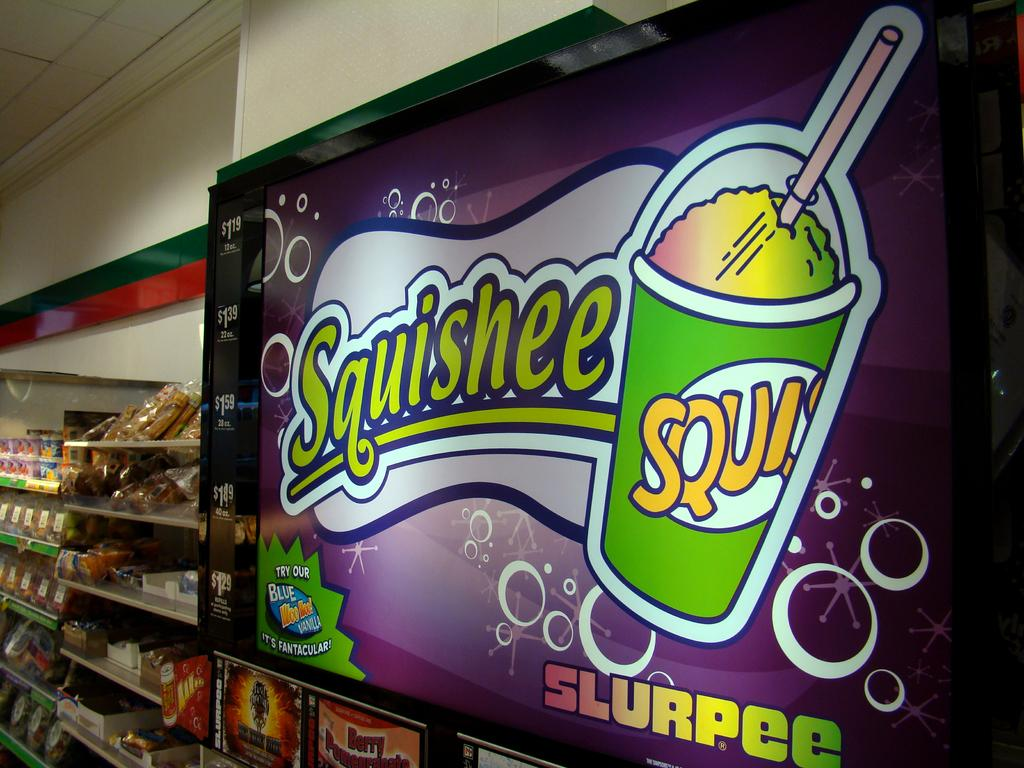Provide a one-sentence caption for the provided image. Squishee slurpee sign in a store that is above the slurpee machine. 